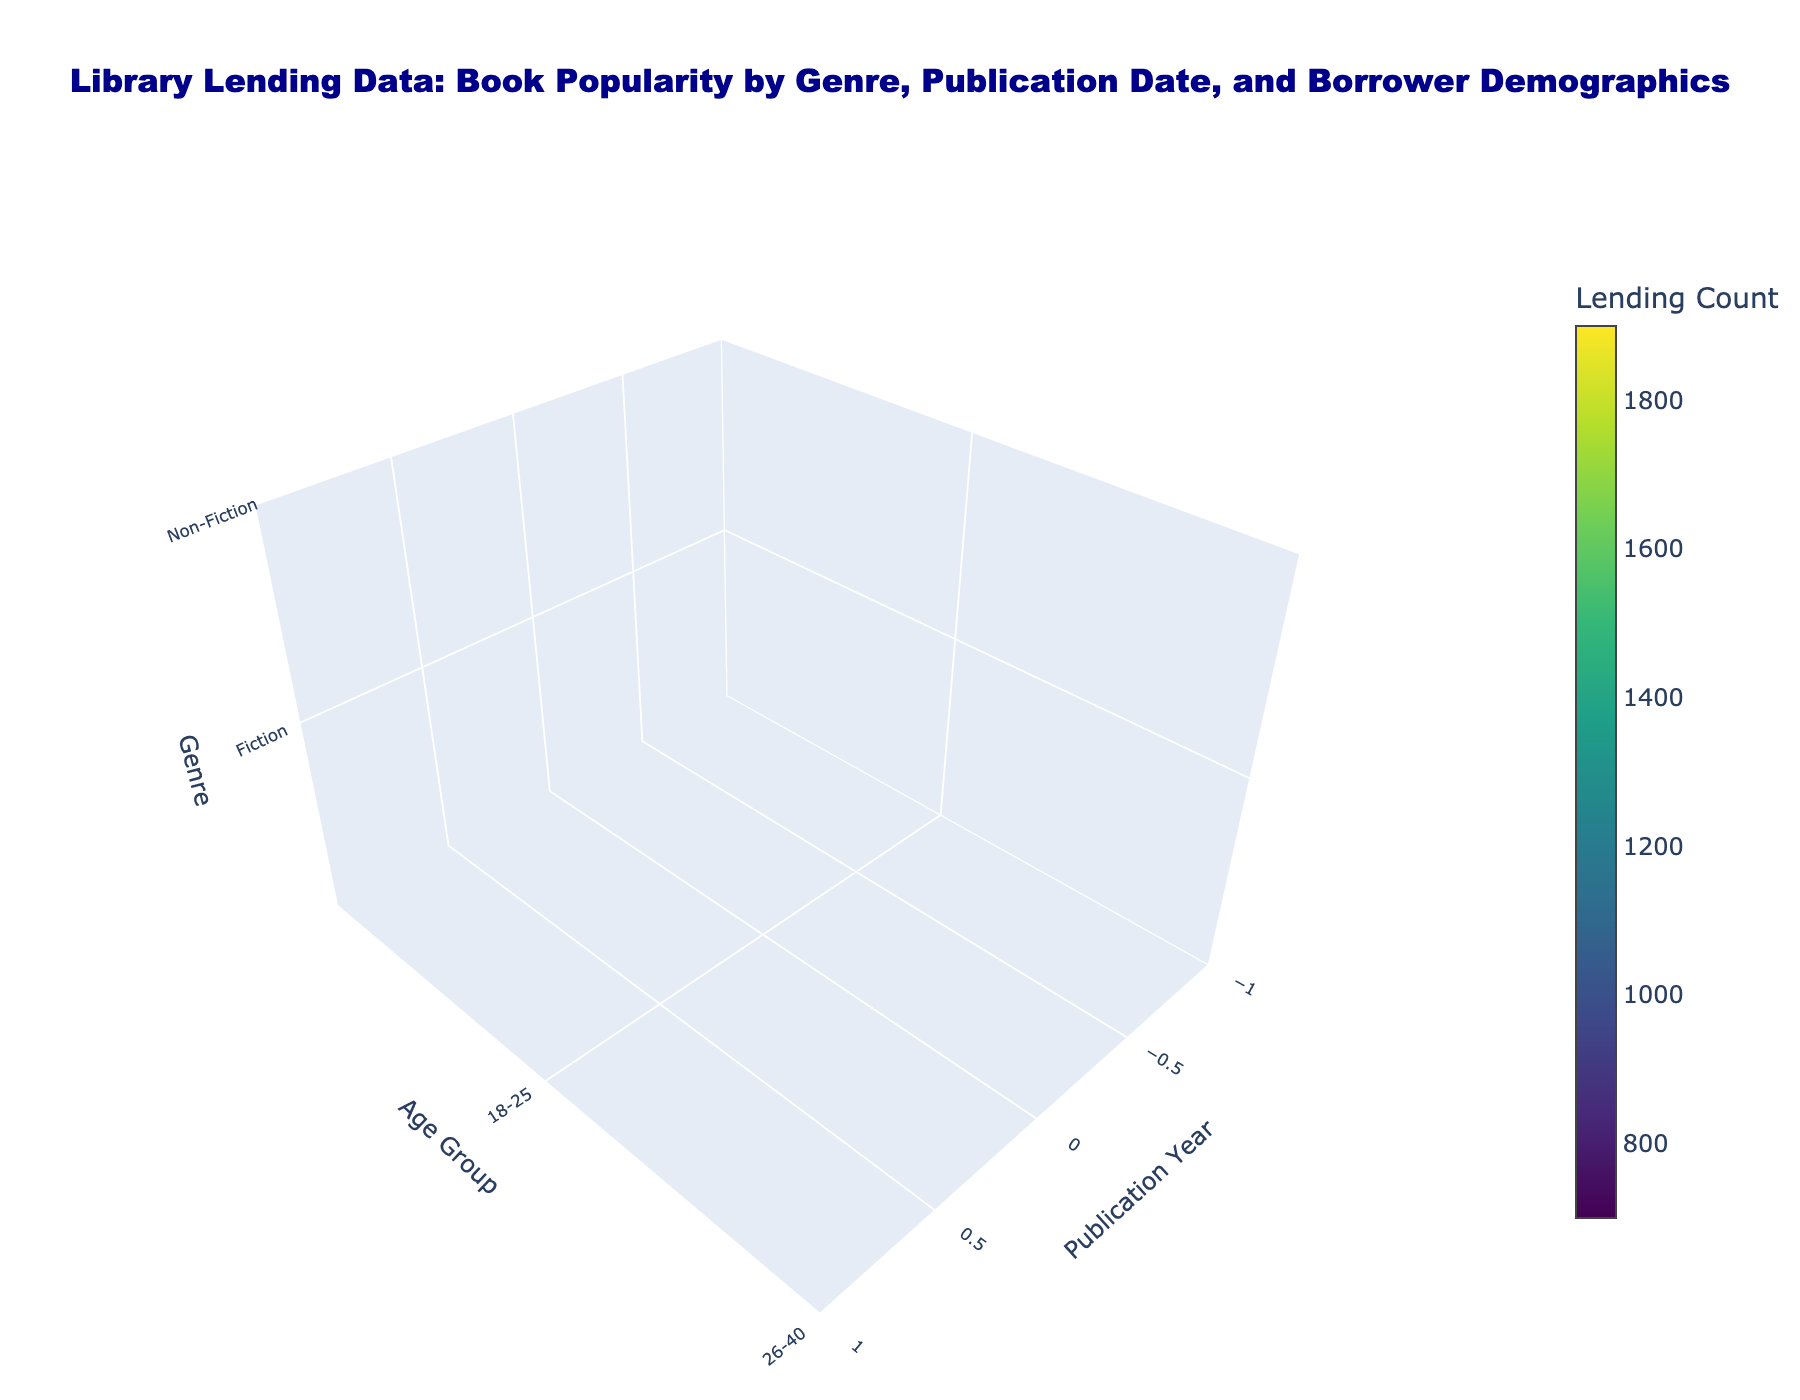What is the title of the figure? The title is displayed at the top of the figure. It clearly states "Library Lending Data: Book Popularity by Genre, Publication Date, and Borrower Demographics."
Answer: Library Lending Data: Book Popularity by Genre, Publication Date, and Borrower Demographics What does the color represent in the 3D volume plot? The color in the plot is linked to the 'Lending Count', with different shades showing varying levels of book lending. It's indicated by the color bar labeled 'Lending Count'.
Answer: Lending Count Which genre had the highest lending count in 2020? By examining the color intensity, darker shades suggest higher lending counts. For 2020, Fiction shows the darkest shade indicating it had the highest lending count.
Answer: Fiction What age group borrowed the most Fiction books in 2015? For 2015 and Fiction, the highest intensity of color is observed for the age group "26-40," suggesting this group borrowed the most.
Answer: 26-40 How does the lending count for Mystery books change from 2010 to 2020 for the 41-60 age group? Look at the color changes specific to Mystery and the age group "41-60" over the years. The intensity increases from a lighter to a darker shade, indicating an increase in lending count from 2010 to 2020.
Answer: Increases Which age group borrowed the least Non-Fiction books in 2010? For Non-Fiction books in 2010, the color is lightest for the age group "60+,” indicating they borrowed the least.
Answer: 60+ Compare the popularity of Fiction and Non-Fiction books in 2015 among the 18-25 age group. Assessing the color for 2015, Fiction has a darker shade compared to Non-Fiction for the age group "18-25," suggesting Fiction is more popular.
Answer: Fiction is more popular How do the lending trends of Fiction books for the 26-40 age group progress from 2010 to 2020? Tracking the color changes for Fiction in the 26-40 age group across the years, the shading gets darker from 2010 to 2020, indicating an upward trend in lending.
Answer: Upward trend What are the visible axes and their titles in the plot? The plot displays three axes: 'Publication Year,' 'Age Group,' and 'Genre,' each clearly labeled on the respective axes.
Answer: Publication Year, Age Group, Genre 